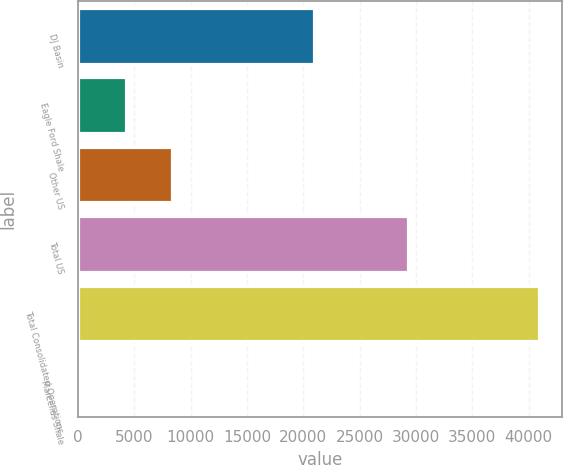<chart> <loc_0><loc_0><loc_500><loc_500><bar_chart><fcel>DJ Basin<fcel>Eagle Ford Shale<fcel>Other US<fcel>Total US<fcel>Total Consolidated Operations<fcel>Marcellus Shale<nl><fcel>20909<fcel>4303.8<fcel>8368.6<fcel>29262<fcel>40887<fcel>239<nl></chart> 